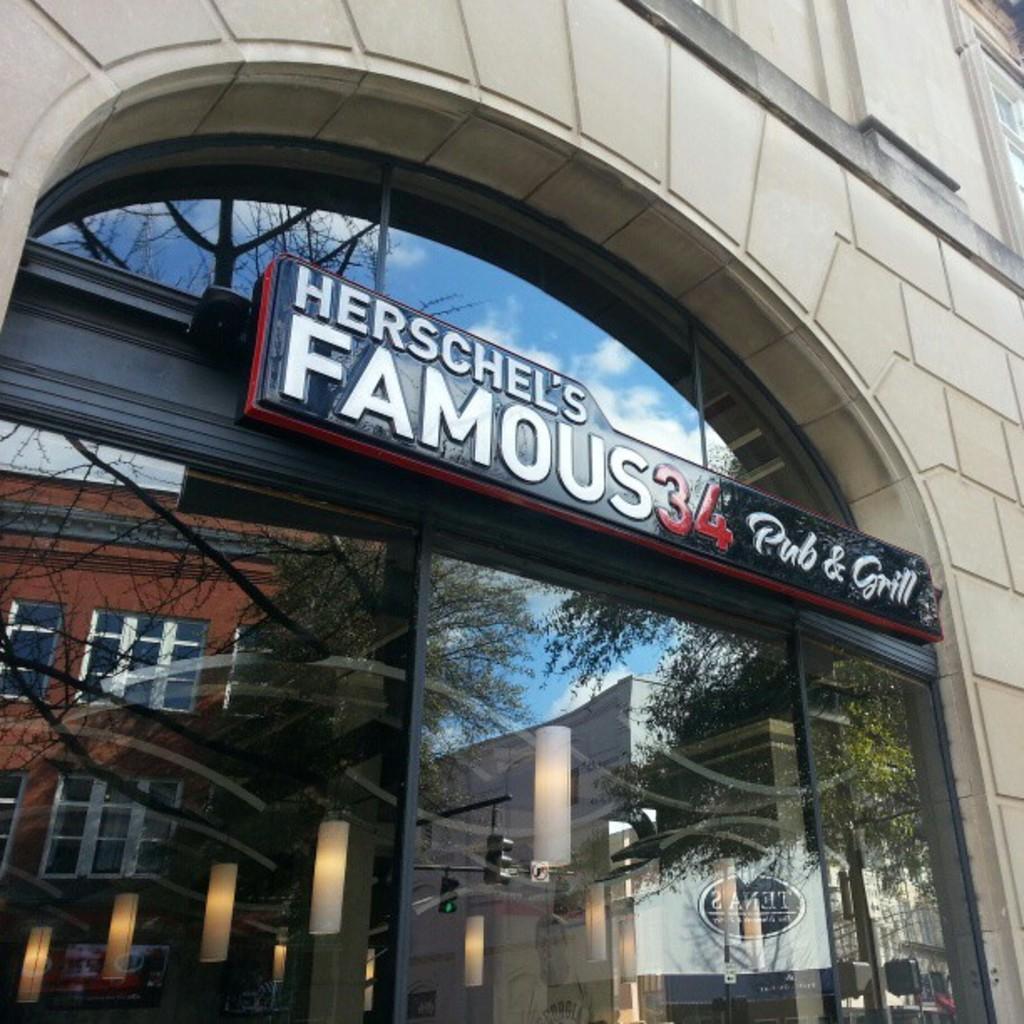In one or two sentences, can you explain what this image depicts? In this image we can see the front view of a building. The door of the building is made up of glass. In the glass reflection of different buildings and trees are there. 